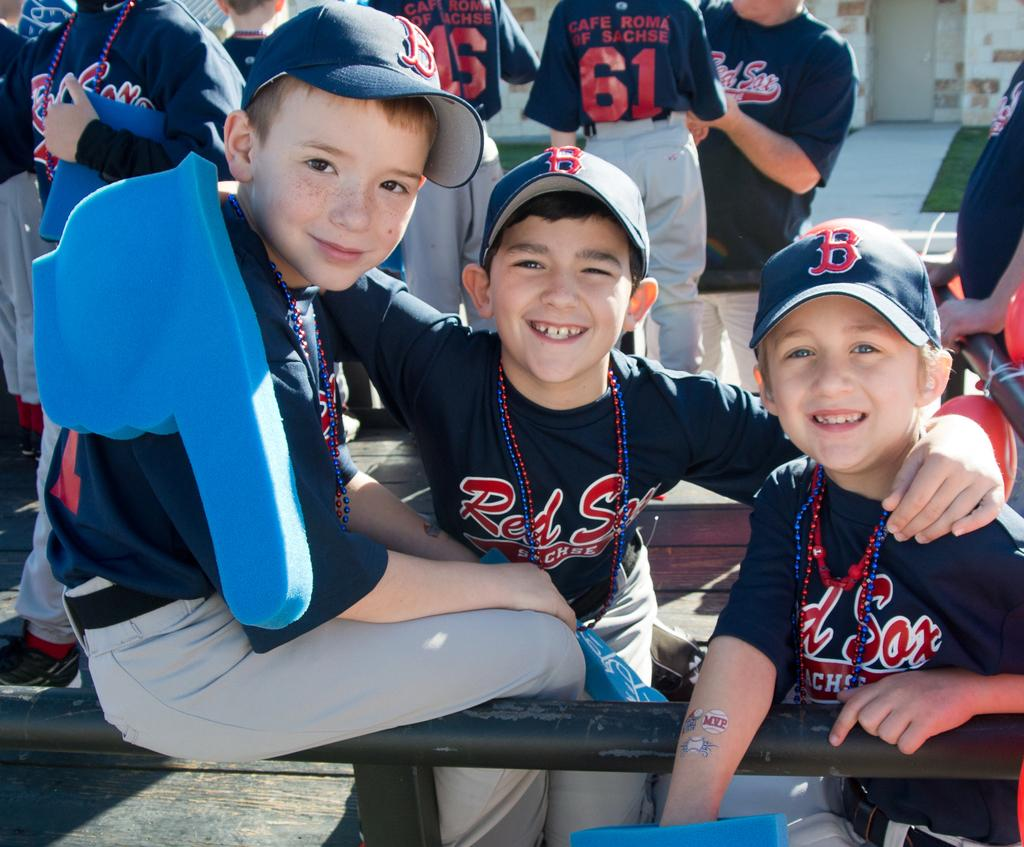<image>
Share a concise interpretation of the image provided. The baseball caps the boys are wearing display the letter B. 